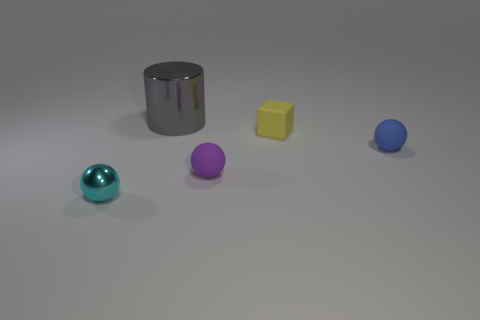Is there any other thing that is the same size as the gray metallic cylinder?
Offer a very short reply. No. Do the tiny blue rubber object and the cyan shiny object have the same shape?
Ensure brevity in your answer.  Yes. What size is the cyan metal sphere?
Make the answer very short. Small. Are there more blue spheres that are behind the big cylinder than small purple rubber things on the right side of the purple rubber thing?
Ensure brevity in your answer.  No. Are there any cylinders on the left side of the blue object?
Provide a succinct answer. Yes. Are there any red metallic cylinders that have the same size as the gray cylinder?
Provide a short and direct response. No. There is a tiny cube that is made of the same material as the blue thing; what is its color?
Your answer should be compact. Yellow. What is the material of the tiny cube?
Offer a terse response. Rubber. There is a blue matte thing; what shape is it?
Your answer should be very brief. Sphere. What number of other metal balls have the same color as the metal ball?
Your answer should be compact. 0. 